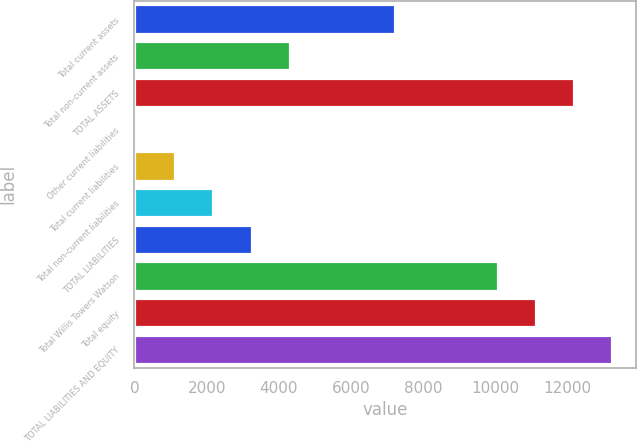Convert chart. <chart><loc_0><loc_0><loc_500><loc_500><bar_chart><fcel>Total current assets<fcel>Total non-current assets<fcel>TOTAL ASSETS<fcel>Other current liabilities<fcel>Total current liabilities<fcel>Total non-current liabilities<fcel>TOTAL LIABILITIES<fcel>Total Willis Towers Watson<fcel>Total equity<fcel>TOTAL LIABILITIES AND EQUITY<nl><fcel>7229<fcel>4301.4<fcel>12177.2<fcel>77<fcel>1133.1<fcel>2189.2<fcel>3245.3<fcel>10065<fcel>11121.1<fcel>13233.3<nl></chart> 